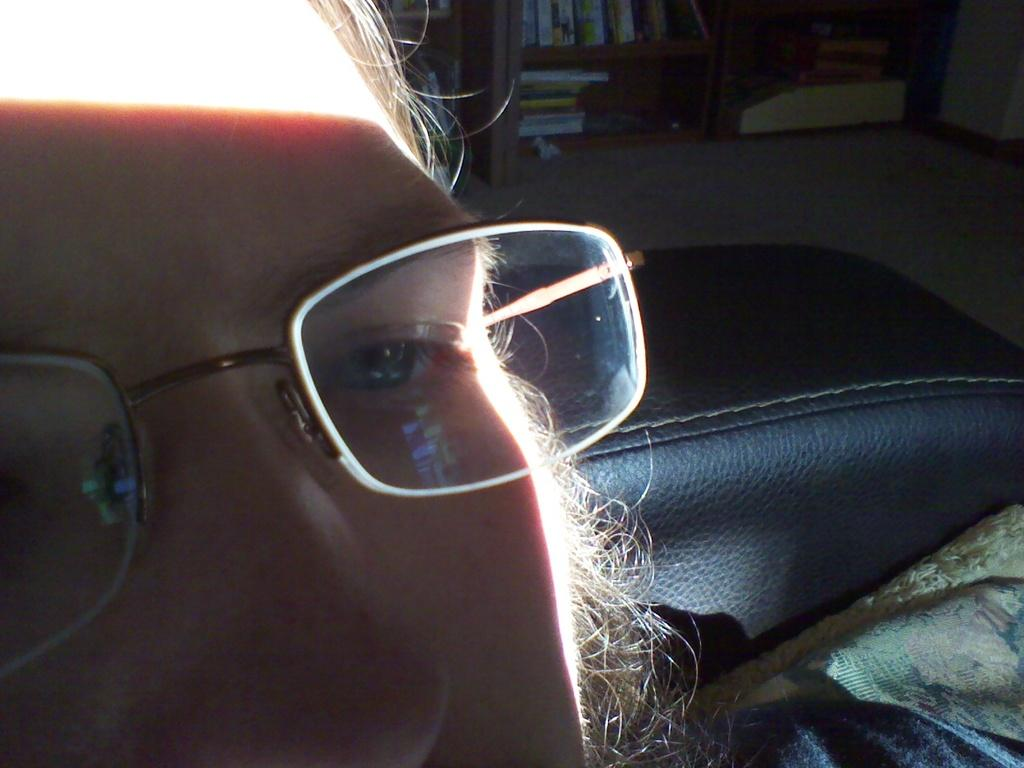What is the main subject of the image? The main subject of the image is many books. How are the books arranged in the image? The books are placed in racks. Can you describe the person in the image? There is a person in the image, and they are wearing spectacles. What type of wave can be seen crashing on the shore in the image? There is no wave or shore present in the image; it features books in racks and a person wearing spectacles. 